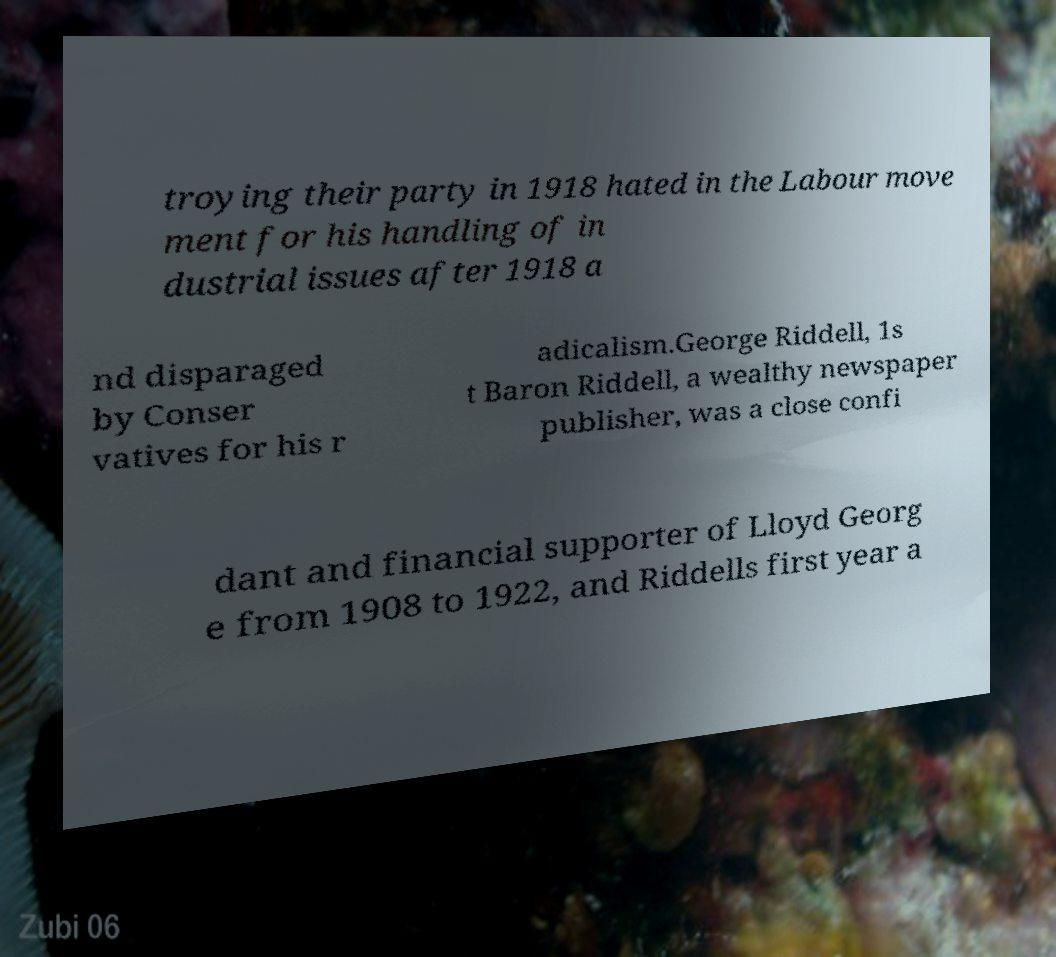Please read and relay the text visible in this image. What does it say? troying their party in 1918 hated in the Labour move ment for his handling of in dustrial issues after 1918 a nd disparaged by Conser vatives for his r adicalism.George Riddell, 1s t Baron Riddell, a wealthy newspaper publisher, was a close confi dant and financial supporter of Lloyd Georg e from 1908 to 1922, and Riddells first year a 